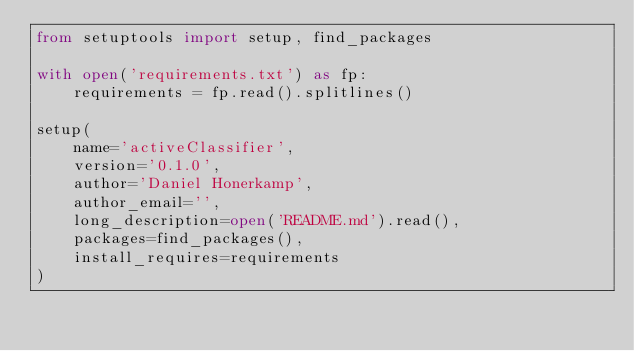<code> <loc_0><loc_0><loc_500><loc_500><_Python_>from setuptools import setup, find_packages

with open('requirements.txt') as fp:
    requirements = fp.read().splitlines()

setup(
    name='activeClassifier',
    version='0.1.0',
    author='Daniel Honerkamp',
    author_email='',
    long_description=open('README.md').read(),
    packages=find_packages(),
    install_requires=requirements
)</code> 